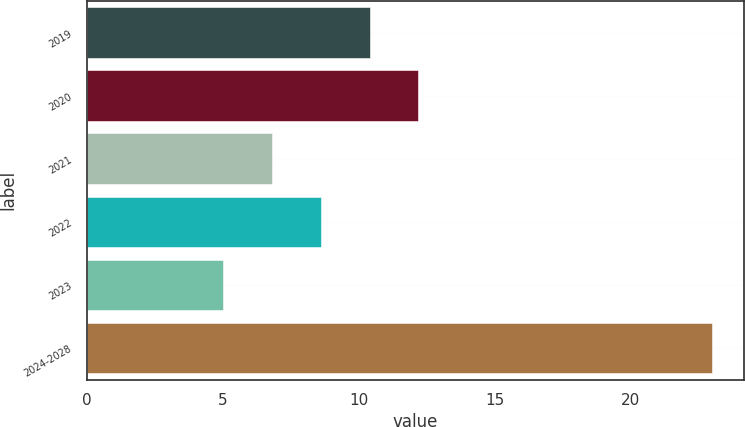Convert chart. <chart><loc_0><loc_0><loc_500><loc_500><bar_chart><fcel>2019<fcel>2020<fcel>2021<fcel>2022<fcel>2023<fcel>2024-2028<nl><fcel>10.4<fcel>12.2<fcel>6.8<fcel>8.6<fcel>5<fcel>23<nl></chart> 